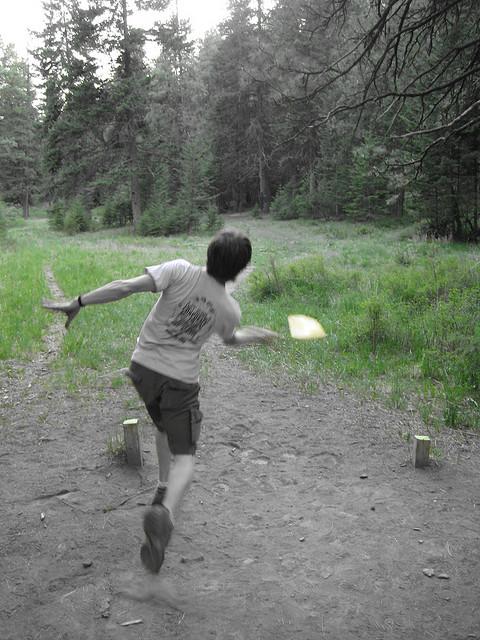Can you see trees?
Short answer required. Yes. Is he standing in dirt?
Quick response, please. Yes. What is the person doing?
Answer briefly. Throwing. 